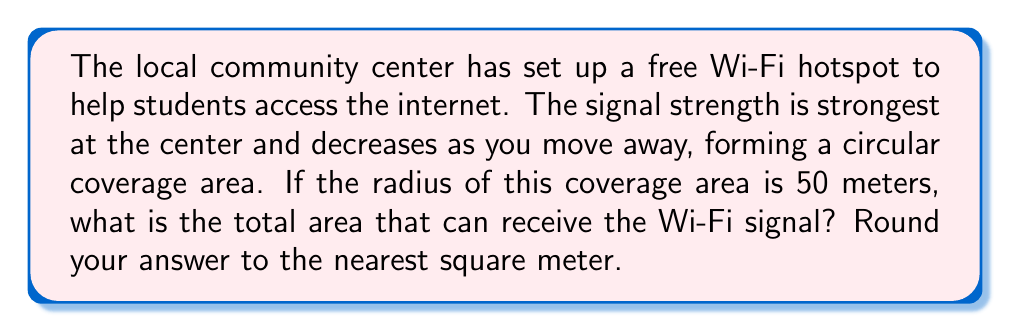Show me your answer to this math problem. Let's approach this step-by-step:

1) The coverage area of the Wi-Fi hotspot forms a circle. To find the area of a circle, we use the formula:

   $$A = \pi r^2$$

   Where $A$ is the area and $r$ is the radius.

2) We're given that the radius is 50 meters. Let's substitute this into our formula:

   $$A = \pi (50)^2$$

3) Now, let's calculate:

   $$A = \pi (2500)$$

4) We can use 3.14159 as an approximation for $\pi$:

   $$A = 3.14159 \times 2500 = 7853.975 \text{ square meters}$$

5) Rounding to the nearest square meter:

   $$A \approx 7854 \text{ square meters}$$

This means that within a circular area of approximately 7854 square meters around the community center, students can access the free Wi-Fi.

[asy]
import geometry;

size(200);
draw(circle((0,0),50));
dot((0,0));
draw((0,0)--(50,0),arrow=Arrow(TeXHead));
label("50 m",((25,0)),S);
label("Wi-Fi Hotspot",(0,0),N);
[/asy]
Answer: 7854 square meters 